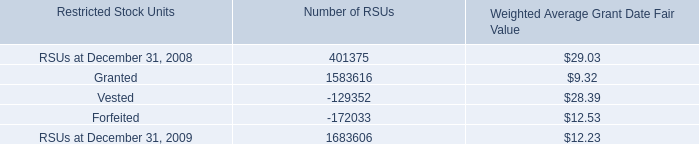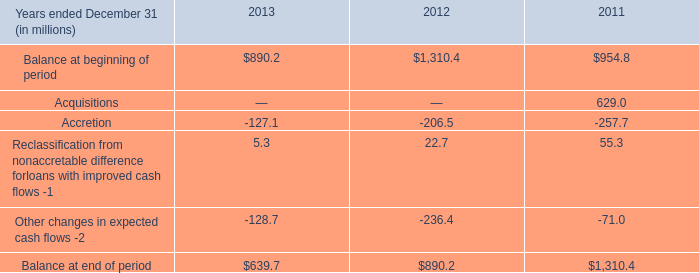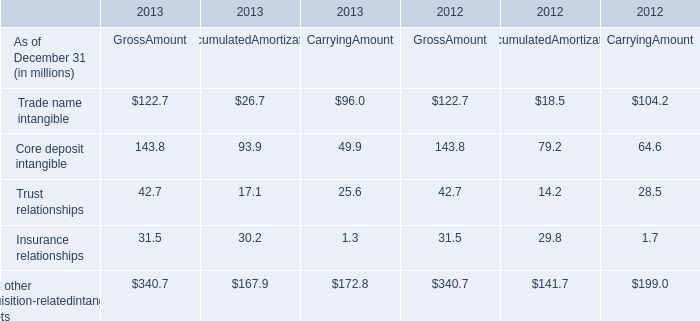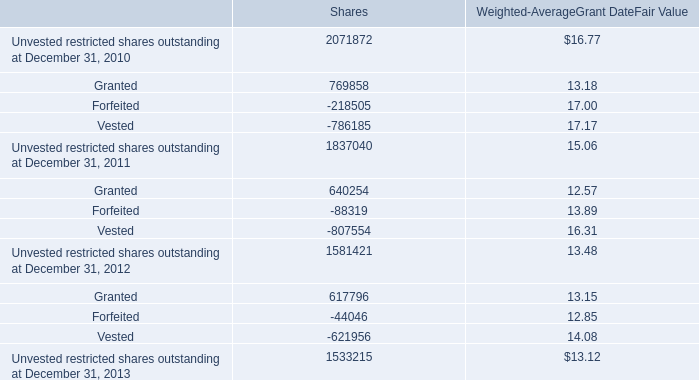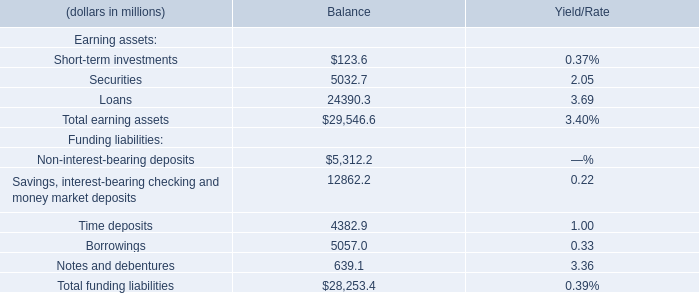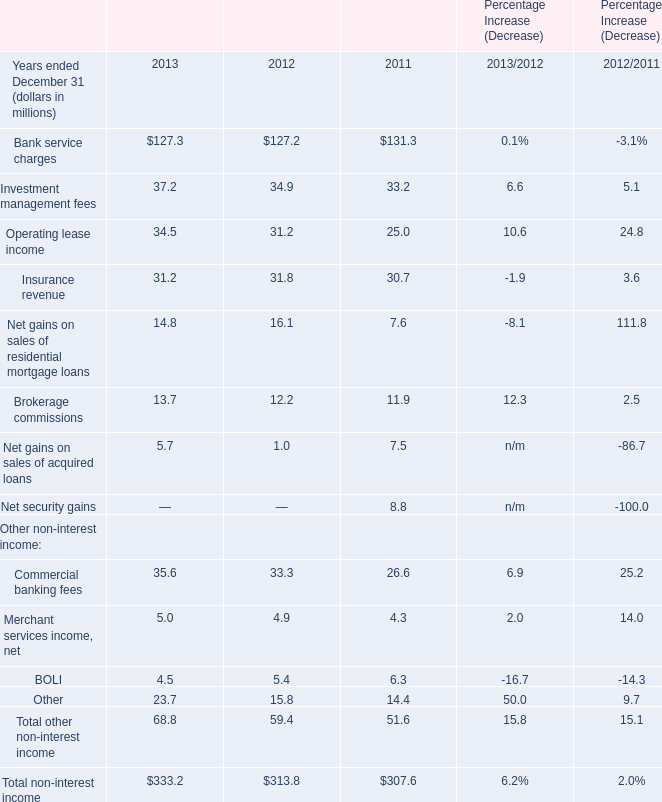If the value of Total earning assets for Balance is larger than the 30 % of Total funding liabilities for Balance,how much is it? (in million) 
Answer: 29546.6. 